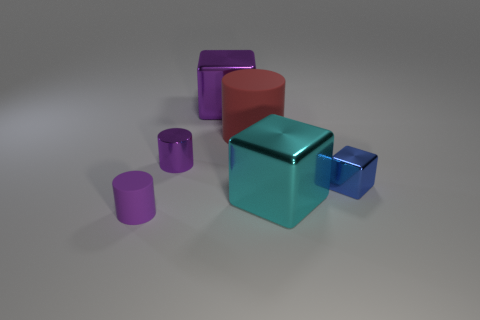What material is the purple object that is both behind the cyan metal cube and in front of the big purple shiny object? The purple object behind the cyan metal cube and in front of the large shiny purple shape appears to be made of the same metal material as the cyan cube, given its reflective surface and similar visual texture. 